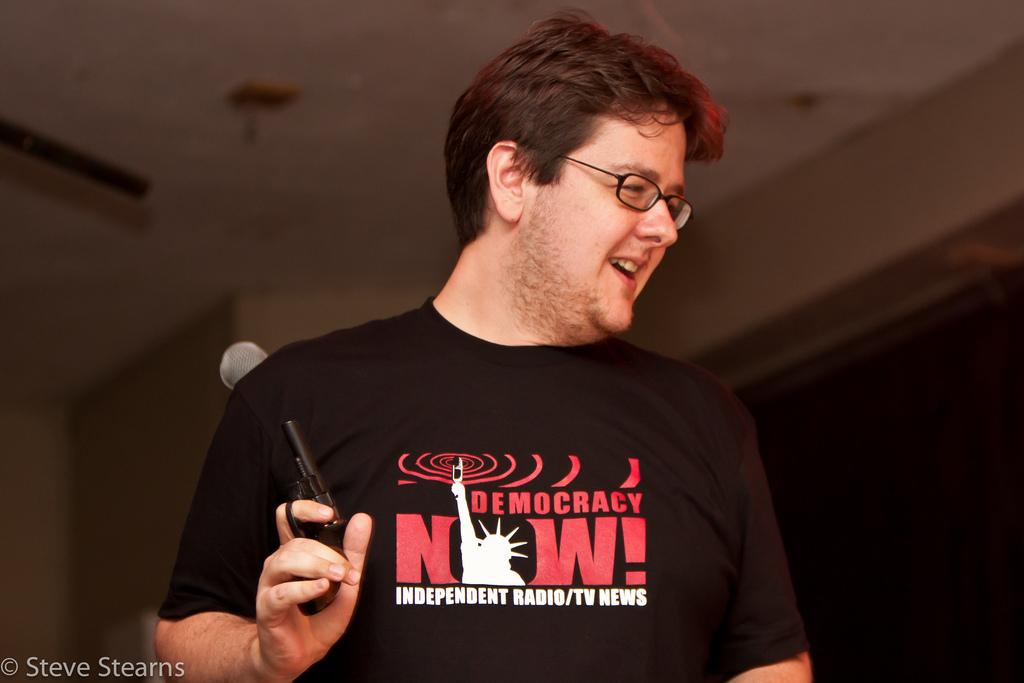What is the main subject of the image? There is a person in the image. What is the person doing in the image? The person is holding an object. What can be seen behind the person? There is a wall behind the person. What part of a building can be seen at the top of the image? The roof is visible at the top of the image. Where is the text located in the image? There is some text in the bottom left corner of the image. What type of receipt is the chicken holding in the image? There is no chicken or receipt present in the image. 